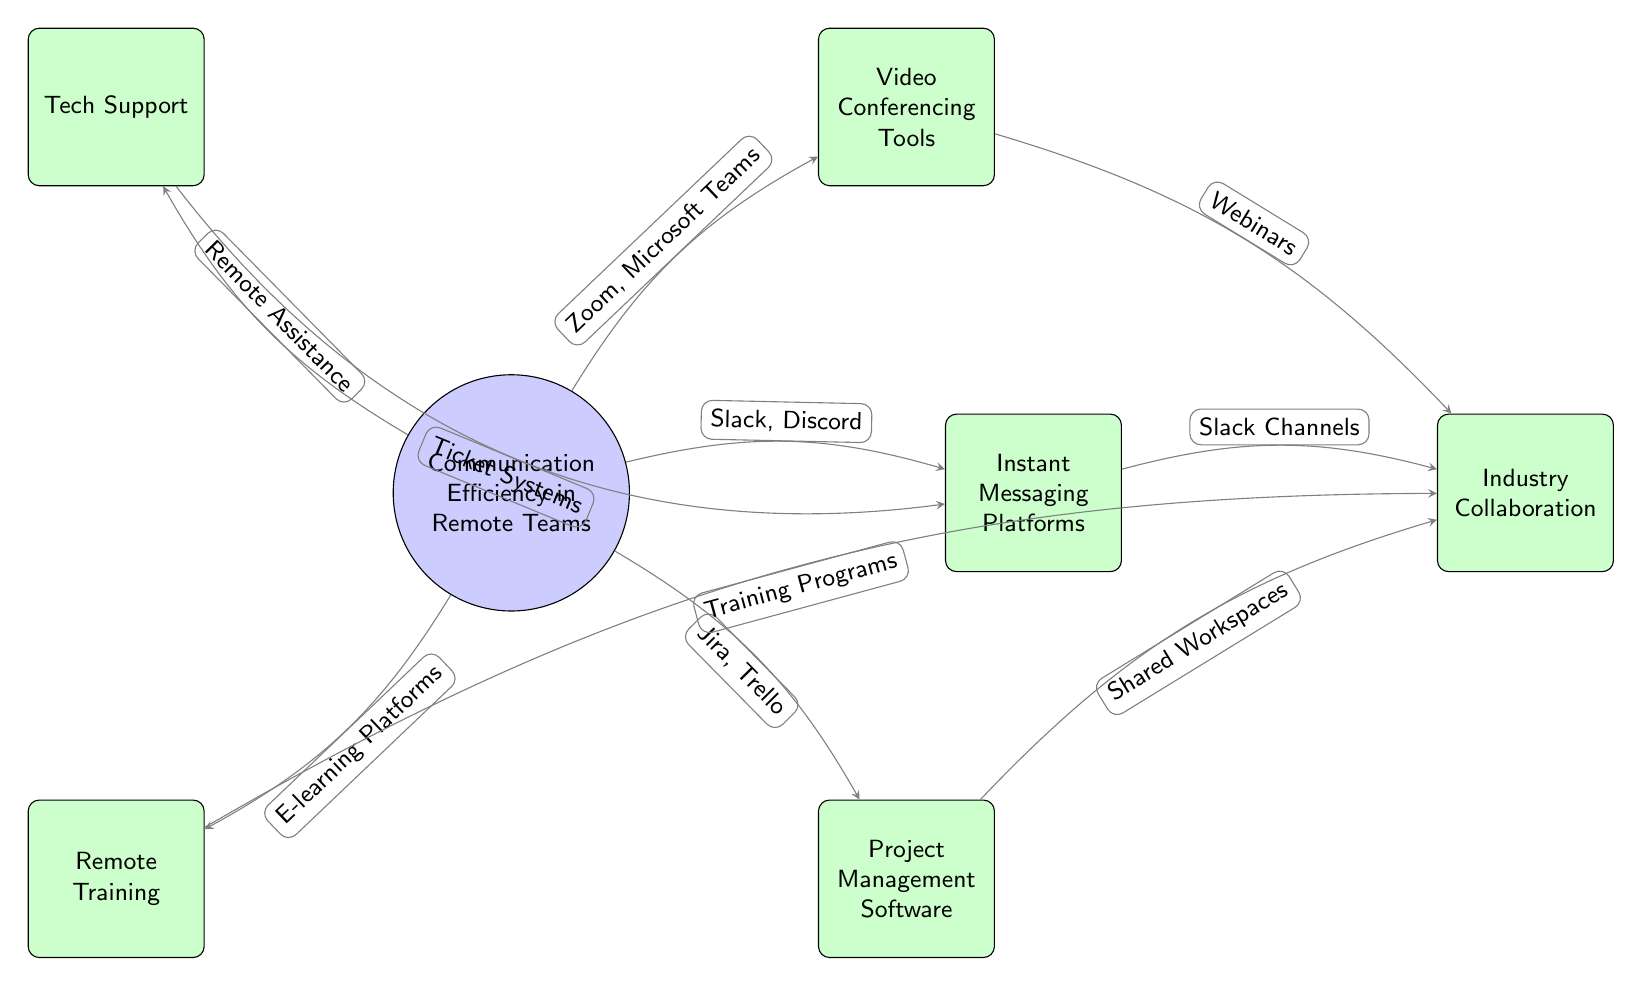What is the main topic of the diagram? The central node labeled "Communication Efficiency in Remote Teams" indicates that this is the primary focus of the diagram.
Answer: Communication Efficiency in Remote Teams How many tools and techniques are directly connected to the main topic? There are six nodes (tools and techniques) that branch out from the main topic, indicating six direct connections.
Answer: 6 Which tool is connected to both video conferencing and industry collaboration? The edge labeled "Webinars" indicates that video conferencing tools lead to industry collaboration.
Answer: Webinars What type of platforms are linked to project management software? The edge leading downwards from project management software indicates "Shared Workspaces," showing the relationship between the two.
Answer: Shared Workspaces Which technique is specifically associated with remote training? The edge labeled "E-learning Platforms" connects remote training to the main topic, illustrating its specific association.
Answer: E-learning Platforms What is the relationship between tech support and instant messaging platforms? The edge labeled "Ticket Systems" illustrates that tech support can provide assistance via instant messaging platforms.
Answer: Ticket Systems What are the two video conferencing tools mentioned in the diagram? The edge directed from the main topic specifies "Zoom" and "Microsoft Teams" as examples of video conferencing tools.
Answer: Zoom, Microsoft Teams How does remote training relate to industry collaboration? The training node connects to industry collaboration through "Training Programs," indicating a contribution of remote training to this area.
Answer: Training Programs Which messaging platforms are mentioned in the diagram? The edge indicates "Slack" and "Discord," showing that these are the messaging platforms referenced.
Answer: Slack, Discord 